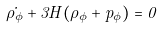<formula> <loc_0><loc_0><loc_500><loc_500>\dot { \rho _ { \phi } } + 3 H ( \rho _ { \phi } + p _ { \phi } ) = 0</formula> 